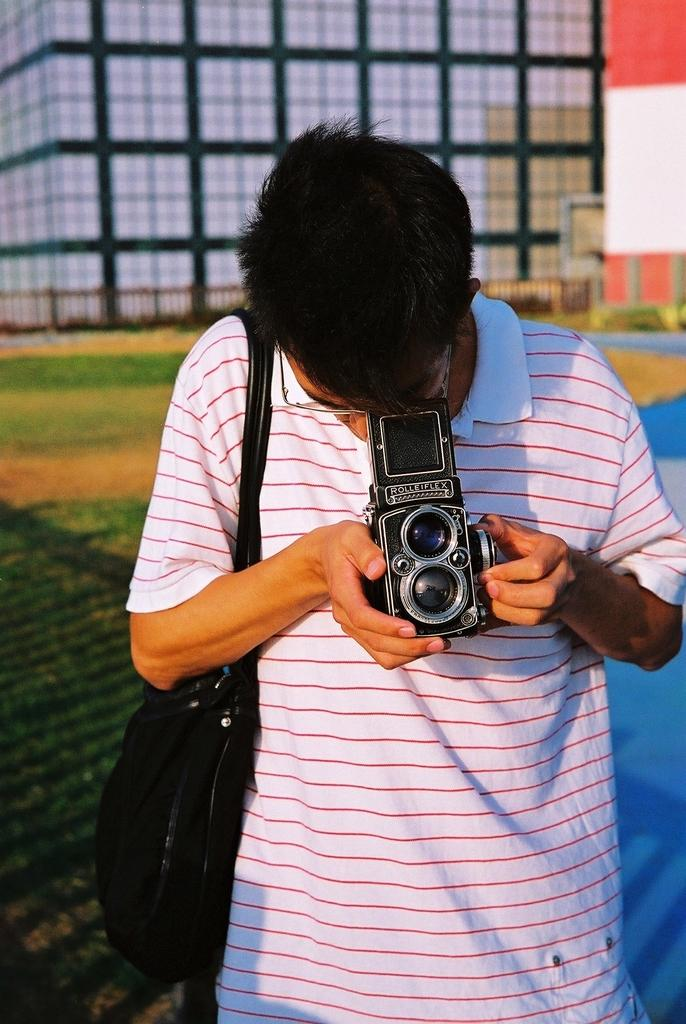What is the man in the image doing? The man is standing in the image and carrying a bag. What is the man holding in the image? The man is holding a camera in the image. What type of vegetation can be seen in the image? There is grass visible in the image. What can be seen in the background of the image? There is a fence and a building in the background of the image. What type of growth can be seen on the man's head in the image? There is no growth visible on the man's head in the image. What type of crown is the man wearing in the image? The man is not wearing a crown in the image. 